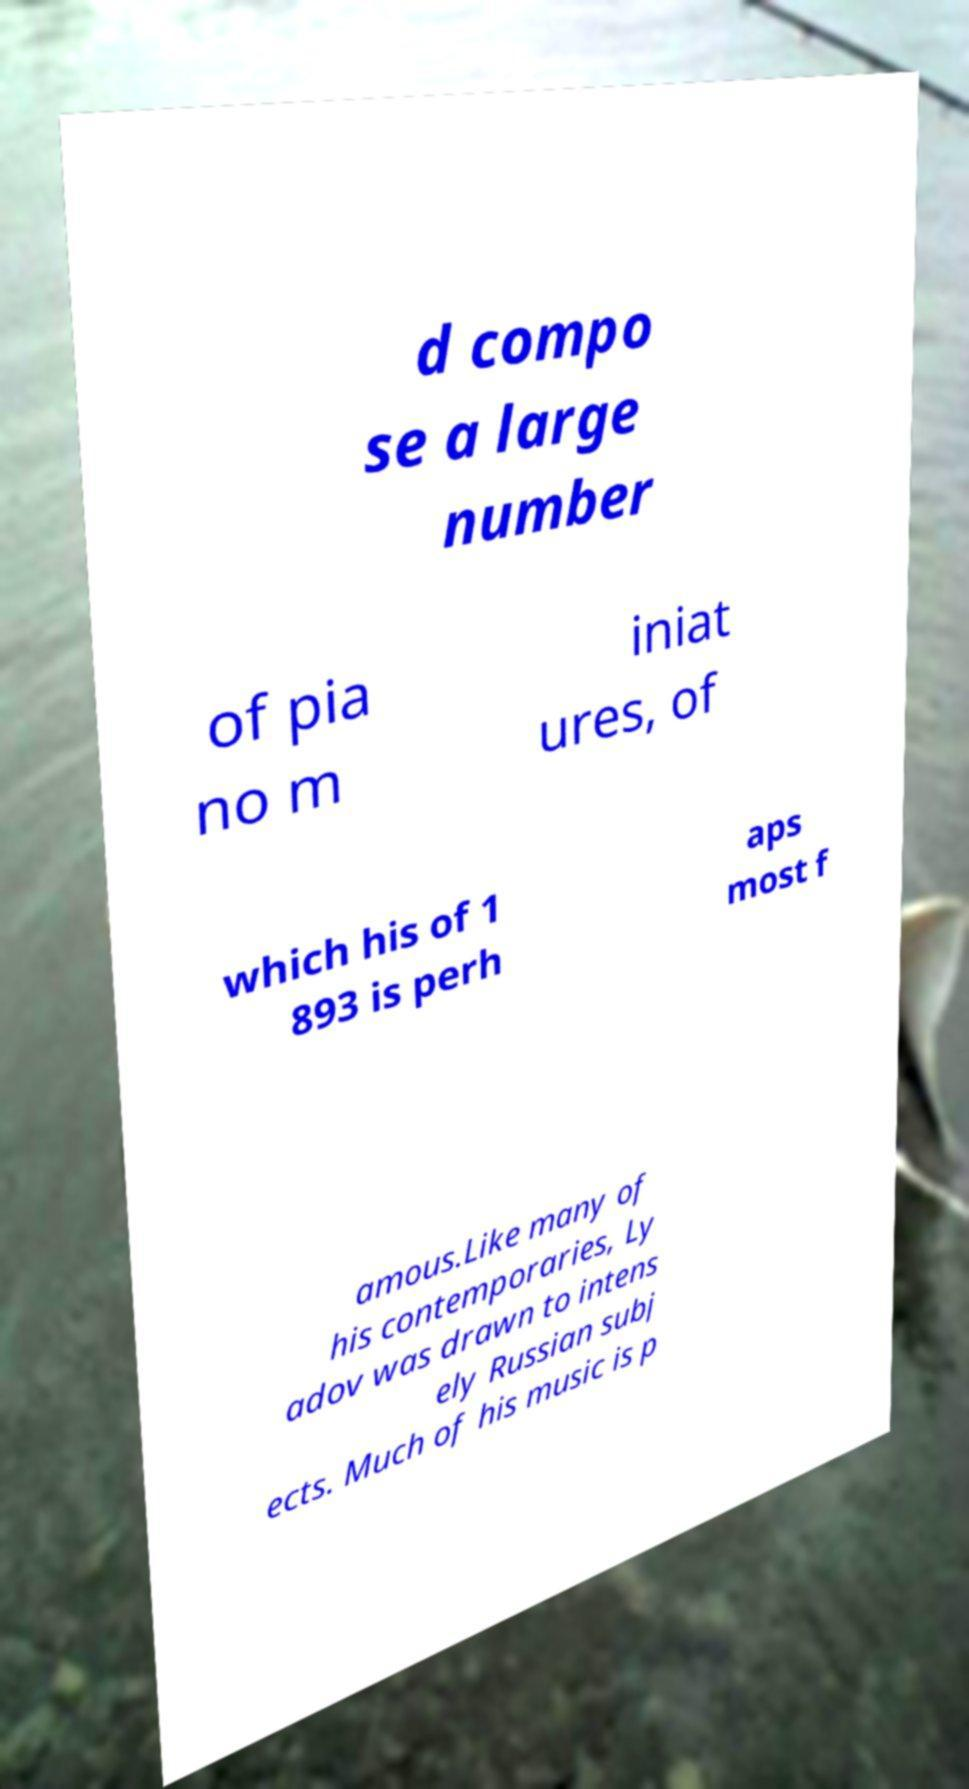What messages or text are displayed in this image? I need them in a readable, typed format. d compo se a large number of pia no m iniat ures, of which his of 1 893 is perh aps most f amous.Like many of his contemporaries, Ly adov was drawn to intens ely Russian subj ects. Much of his music is p 